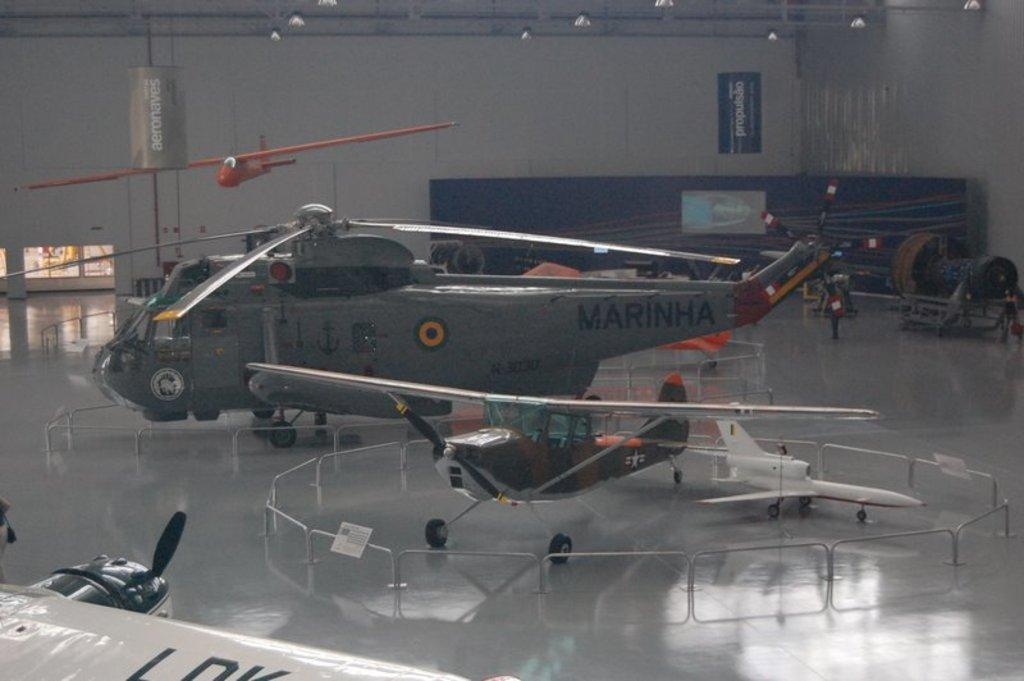What is the main subject of the image? The main subject of the image is airplanes. Can you describe the surroundings of the airplanes? There are walls visible in the image. What type of harmony can be heard between the cats in the image? There are no cats present in the image, so it is not possible to determine any harmony between them. 